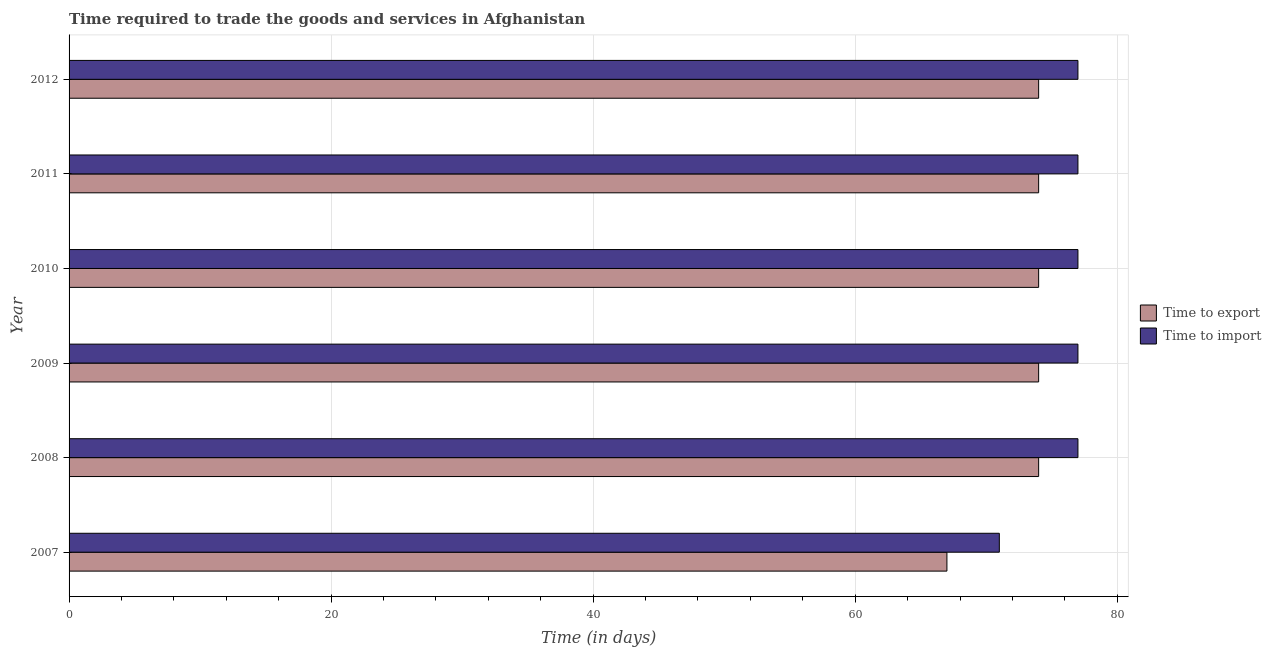How many different coloured bars are there?
Your answer should be compact. 2. Are the number of bars on each tick of the Y-axis equal?
Your response must be concise. Yes. How many bars are there on the 3rd tick from the top?
Make the answer very short. 2. In how many cases, is the number of bars for a given year not equal to the number of legend labels?
Provide a short and direct response. 0. What is the time to export in 2007?
Provide a short and direct response. 67. Across all years, what is the maximum time to import?
Provide a short and direct response. 77. Across all years, what is the minimum time to import?
Your answer should be compact. 71. In which year was the time to export minimum?
Keep it short and to the point. 2007. What is the total time to import in the graph?
Provide a short and direct response. 456. What is the difference between the time to export in 2010 and the time to import in 2011?
Offer a very short reply. -3. What is the average time to export per year?
Offer a terse response. 72.83. In the year 2010, what is the difference between the time to export and time to import?
Provide a succinct answer. -3. In how many years, is the time to export greater than 56 days?
Offer a very short reply. 6. What is the ratio of the time to export in 2009 to that in 2010?
Make the answer very short. 1. Is the time to import in 2011 less than that in 2012?
Offer a very short reply. No. Is the difference between the time to export in 2009 and 2011 greater than the difference between the time to import in 2009 and 2011?
Give a very brief answer. No. What is the difference between the highest and the lowest time to export?
Keep it short and to the point. 7. What does the 1st bar from the top in 2007 represents?
Your answer should be compact. Time to import. What does the 1st bar from the bottom in 2011 represents?
Offer a terse response. Time to export. How many bars are there?
Offer a very short reply. 12. How many years are there in the graph?
Make the answer very short. 6. What is the difference between two consecutive major ticks on the X-axis?
Offer a very short reply. 20. What is the title of the graph?
Give a very brief answer. Time required to trade the goods and services in Afghanistan. What is the label or title of the X-axis?
Give a very brief answer. Time (in days). What is the Time (in days) in Time to export in 2009?
Ensure brevity in your answer.  74. What is the Time (in days) of Time to import in 2011?
Your answer should be very brief. 77. What is the Time (in days) of Time to export in 2012?
Provide a short and direct response. 74. What is the total Time (in days) in Time to export in the graph?
Ensure brevity in your answer.  437. What is the total Time (in days) in Time to import in the graph?
Offer a very short reply. 456. What is the difference between the Time (in days) of Time to export in 2007 and that in 2008?
Provide a succinct answer. -7. What is the difference between the Time (in days) in Time to import in 2007 and that in 2008?
Ensure brevity in your answer.  -6. What is the difference between the Time (in days) in Time to export in 2007 and that in 2010?
Keep it short and to the point. -7. What is the difference between the Time (in days) of Time to import in 2007 and that in 2010?
Your answer should be very brief. -6. What is the difference between the Time (in days) in Time to export in 2007 and that in 2011?
Ensure brevity in your answer.  -7. What is the difference between the Time (in days) in Time to import in 2008 and that in 2009?
Your answer should be compact. 0. What is the difference between the Time (in days) in Time to import in 2008 and that in 2010?
Provide a short and direct response. 0. What is the difference between the Time (in days) of Time to import in 2008 and that in 2011?
Provide a succinct answer. 0. What is the difference between the Time (in days) in Time to export in 2009 and that in 2010?
Make the answer very short. 0. What is the difference between the Time (in days) of Time to import in 2009 and that in 2012?
Ensure brevity in your answer.  0. What is the difference between the Time (in days) of Time to export in 2010 and that in 2011?
Offer a terse response. 0. What is the difference between the Time (in days) of Time to import in 2010 and that in 2011?
Keep it short and to the point. 0. What is the difference between the Time (in days) in Time to export in 2011 and that in 2012?
Ensure brevity in your answer.  0. What is the difference between the Time (in days) in Time to export in 2007 and the Time (in days) in Time to import in 2009?
Your answer should be compact. -10. What is the difference between the Time (in days) in Time to export in 2007 and the Time (in days) in Time to import in 2010?
Keep it short and to the point. -10. What is the difference between the Time (in days) in Time to export in 2007 and the Time (in days) in Time to import in 2011?
Your response must be concise. -10. What is the difference between the Time (in days) of Time to export in 2008 and the Time (in days) of Time to import in 2009?
Your answer should be very brief. -3. What is the difference between the Time (in days) of Time to export in 2008 and the Time (in days) of Time to import in 2011?
Provide a short and direct response. -3. What is the difference between the Time (in days) of Time to export in 2009 and the Time (in days) of Time to import in 2010?
Your response must be concise. -3. What is the difference between the Time (in days) of Time to export in 2010 and the Time (in days) of Time to import in 2011?
Your answer should be compact. -3. What is the average Time (in days) in Time to export per year?
Your answer should be very brief. 72.83. What is the average Time (in days) of Time to import per year?
Keep it short and to the point. 76. In the year 2007, what is the difference between the Time (in days) in Time to export and Time (in days) in Time to import?
Your answer should be very brief. -4. In the year 2009, what is the difference between the Time (in days) in Time to export and Time (in days) in Time to import?
Keep it short and to the point. -3. In the year 2011, what is the difference between the Time (in days) in Time to export and Time (in days) in Time to import?
Your response must be concise. -3. What is the ratio of the Time (in days) of Time to export in 2007 to that in 2008?
Your answer should be very brief. 0.91. What is the ratio of the Time (in days) of Time to import in 2007 to that in 2008?
Your response must be concise. 0.92. What is the ratio of the Time (in days) in Time to export in 2007 to that in 2009?
Ensure brevity in your answer.  0.91. What is the ratio of the Time (in days) in Time to import in 2007 to that in 2009?
Offer a very short reply. 0.92. What is the ratio of the Time (in days) in Time to export in 2007 to that in 2010?
Make the answer very short. 0.91. What is the ratio of the Time (in days) of Time to import in 2007 to that in 2010?
Give a very brief answer. 0.92. What is the ratio of the Time (in days) of Time to export in 2007 to that in 2011?
Provide a succinct answer. 0.91. What is the ratio of the Time (in days) in Time to import in 2007 to that in 2011?
Offer a terse response. 0.92. What is the ratio of the Time (in days) in Time to export in 2007 to that in 2012?
Offer a very short reply. 0.91. What is the ratio of the Time (in days) of Time to import in 2007 to that in 2012?
Offer a very short reply. 0.92. What is the ratio of the Time (in days) in Time to export in 2008 to that in 2009?
Make the answer very short. 1. What is the ratio of the Time (in days) of Time to import in 2008 to that in 2009?
Provide a short and direct response. 1. What is the ratio of the Time (in days) in Time to export in 2008 to that in 2010?
Offer a terse response. 1. What is the ratio of the Time (in days) in Time to import in 2008 to that in 2010?
Provide a short and direct response. 1. What is the ratio of the Time (in days) in Time to import in 2008 to that in 2011?
Offer a very short reply. 1. What is the ratio of the Time (in days) of Time to export in 2008 to that in 2012?
Your response must be concise. 1. What is the ratio of the Time (in days) in Time to import in 2009 to that in 2011?
Offer a terse response. 1. What is the ratio of the Time (in days) of Time to import in 2009 to that in 2012?
Ensure brevity in your answer.  1. What is the ratio of the Time (in days) of Time to import in 2010 to that in 2012?
Give a very brief answer. 1. What is the ratio of the Time (in days) in Time to export in 2011 to that in 2012?
Give a very brief answer. 1. What is the difference between the highest and the second highest Time (in days) in Time to import?
Your answer should be compact. 0. What is the difference between the highest and the lowest Time (in days) of Time to export?
Keep it short and to the point. 7. 